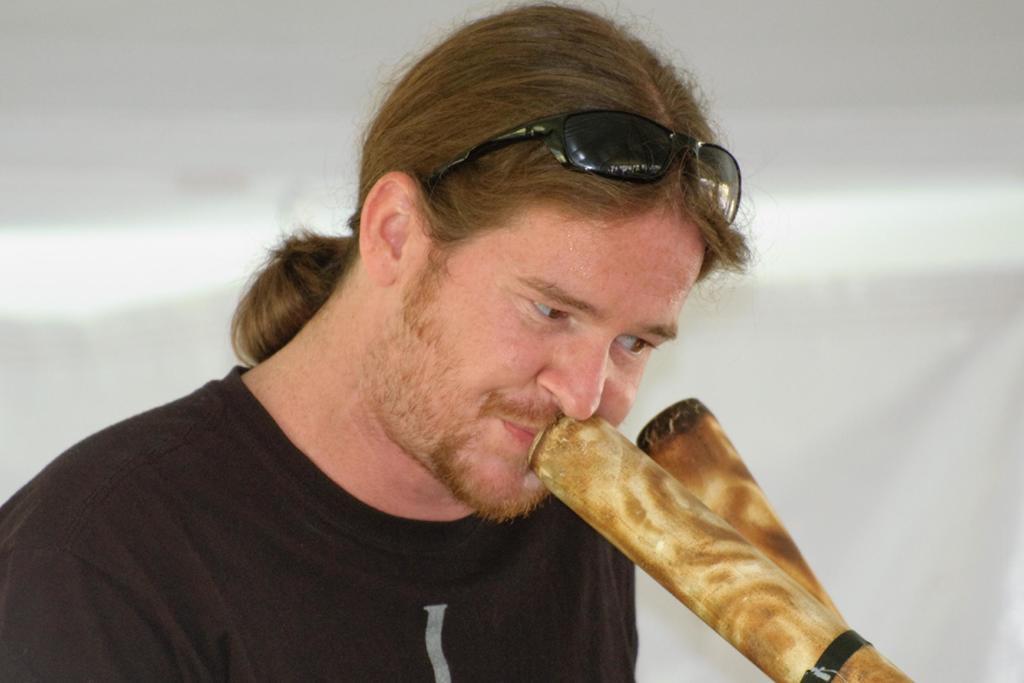Can you describe this image briefly? In this picture we can see a man, there are two bamboo sticks in front of him, he wore goggles, there is a blurry background. 